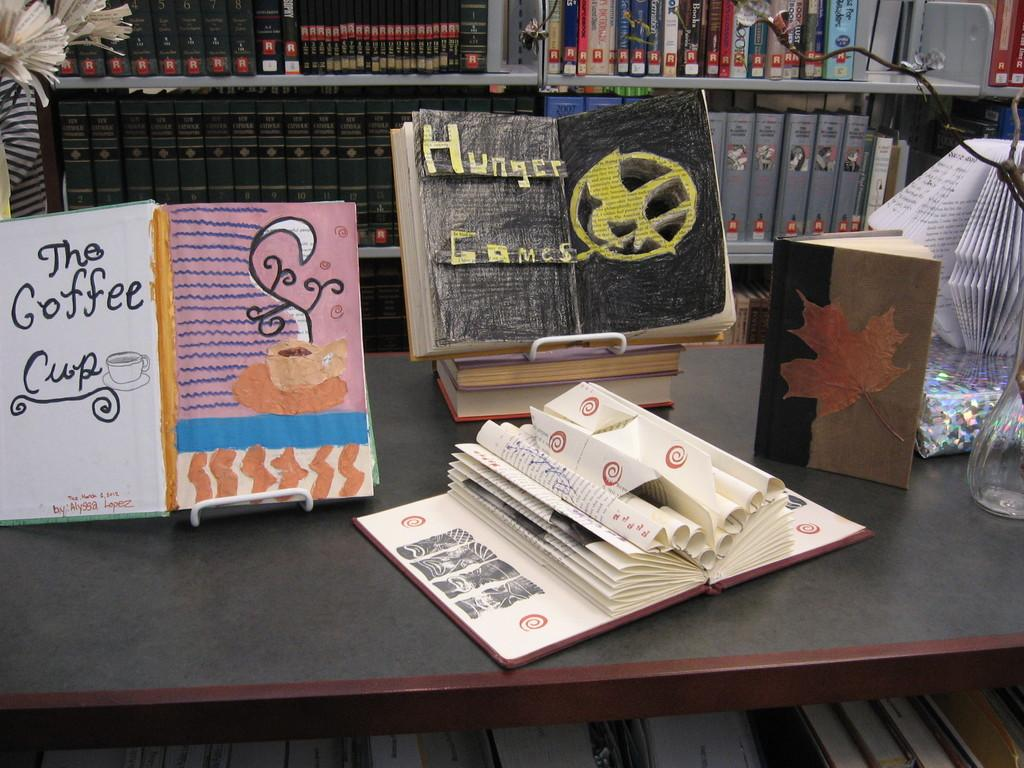What objects are on the table in the image? There are books on the table in the image. Where is the flower vase located on the table? The flower vase is on the right side corner of the table. What can be seen in the background of the image? There are racks with books in the background. How many cakes are on the table in the image? There are no cakes present in the image; it features books and a flower vase on the table. 